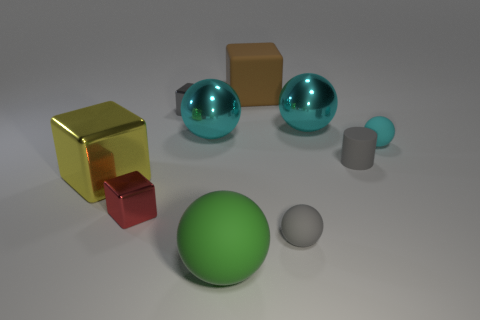Subtract all cyan spheres. How many were subtracted if there are2cyan spheres left? 1 Subtract all brown cubes. How many cubes are left? 3 Subtract all cyan spheres. How many spheres are left? 2 Subtract all cylinders. How many objects are left? 9 Subtract 1 cylinders. How many cylinders are left? 0 Add 4 tiny cylinders. How many tiny cylinders are left? 5 Add 8 gray cylinders. How many gray cylinders exist? 9 Subtract 0 blue spheres. How many objects are left? 10 Subtract all purple spheres. Subtract all green cubes. How many spheres are left? 5 Subtract all red cylinders. How many green blocks are left? 0 